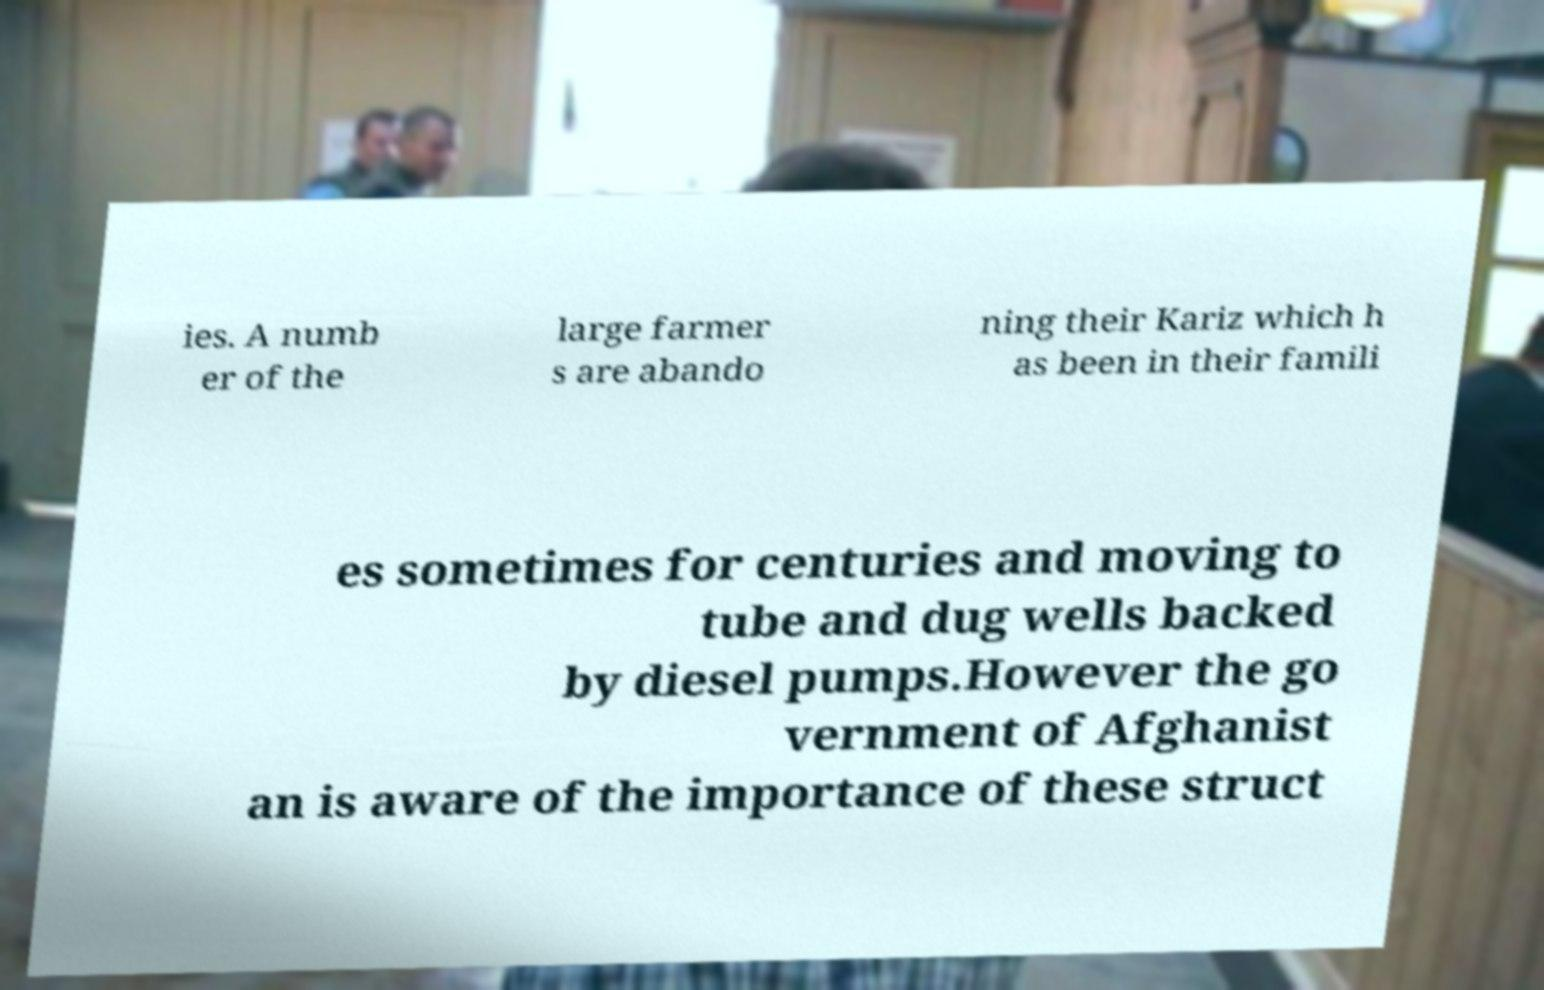For documentation purposes, I need the text within this image transcribed. Could you provide that? ies. A numb er of the large farmer s are abando ning their Kariz which h as been in their famili es sometimes for centuries and moving to tube and dug wells backed by diesel pumps.However the go vernment of Afghanist an is aware of the importance of these struct 